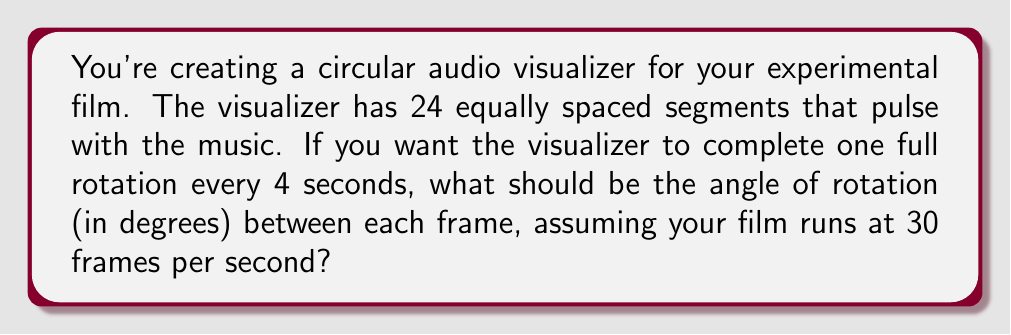Provide a solution to this math problem. Let's approach this step-by-step:

1) First, let's calculate how many frames it takes to complete one full rotation:
   4 seconds × 30 frames/second = 120 frames

2) A full rotation is 360°. We need to find the angle rotated per frame:
   $$\text{Angle per frame} = \frac{360°}{120 \text{ frames}}$$

3) Simplifying this fraction:
   $$\frac{360°}{120} = \frac{3°}{1} = 3°$$

4) Therefore, the visualizer needs to rotate 3° per frame to complete a full rotation in 4 seconds.

5) We can verify this:
   3° per frame × 30 frames per second × 4 seconds = 360°

This confirms that our calculation is correct, as it results in a full 360° rotation in 4 seconds.
Answer: 3° 